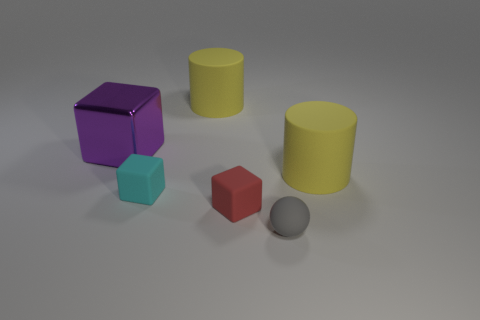Are there any rubber cylinders to the left of the tiny cyan block?
Your response must be concise. No. What number of other tiny red objects have the same shape as the tiny red matte thing?
Offer a terse response. 0. Is the material of the red object the same as the tiny cyan object on the left side of the gray matte ball?
Ensure brevity in your answer.  Yes. What number of large blue metal blocks are there?
Your answer should be compact. 0. What size is the cylinder that is to the left of the tiny red matte thing?
Make the answer very short. Large. How many matte blocks are the same size as the gray sphere?
Provide a succinct answer. 2. There is a thing that is both behind the ball and on the right side of the red cube; what material is it?
Give a very brief answer. Rubber. What is the material of the red thing that is the same size as the gray thing?
Offer a very short reply. Rubber. There is a yellow matte object in front of the yellow rubber object behind the block that is behind the cyan object; how big is it?
Your answer should be very brief. Large. What size is the cyan cube that is the same material as the red block?
Make the answer very short. Small. 